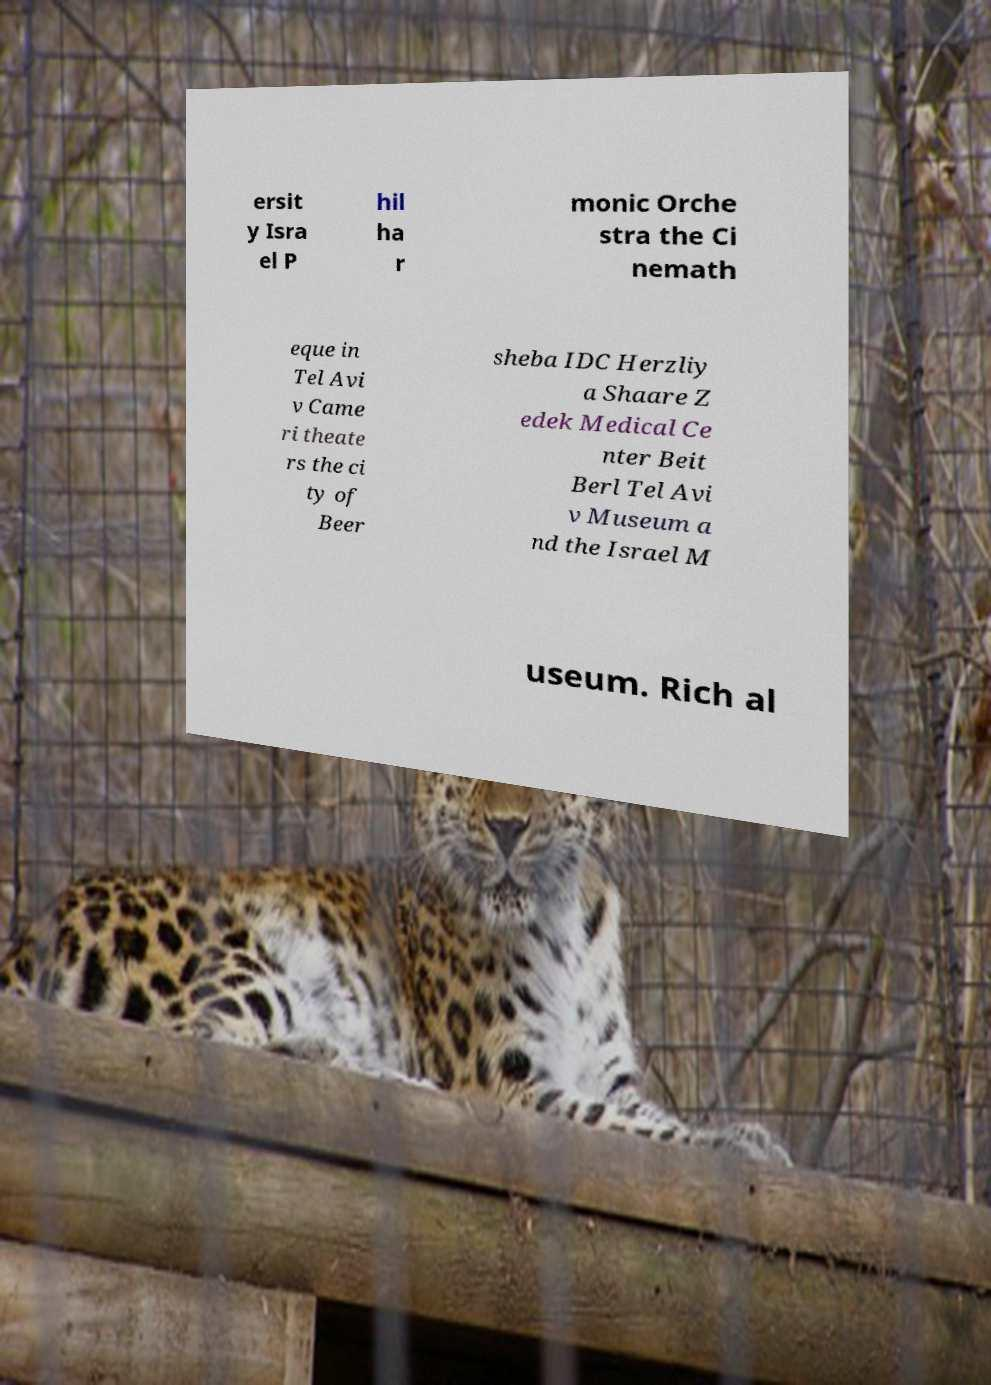Could you assist in decoding the text presented in this image and type it out clearly? ersit y Isra el P hil ha r monic Orche stra the Ci nemath eque in Tel Avi v Came ri theate rs the ci ty of Beer sheba IDC Herzliy a Shaare Z edek Medical Ce nter Beit Berl Tel Avi v Museum a nd the Israel M useum. Rich al 